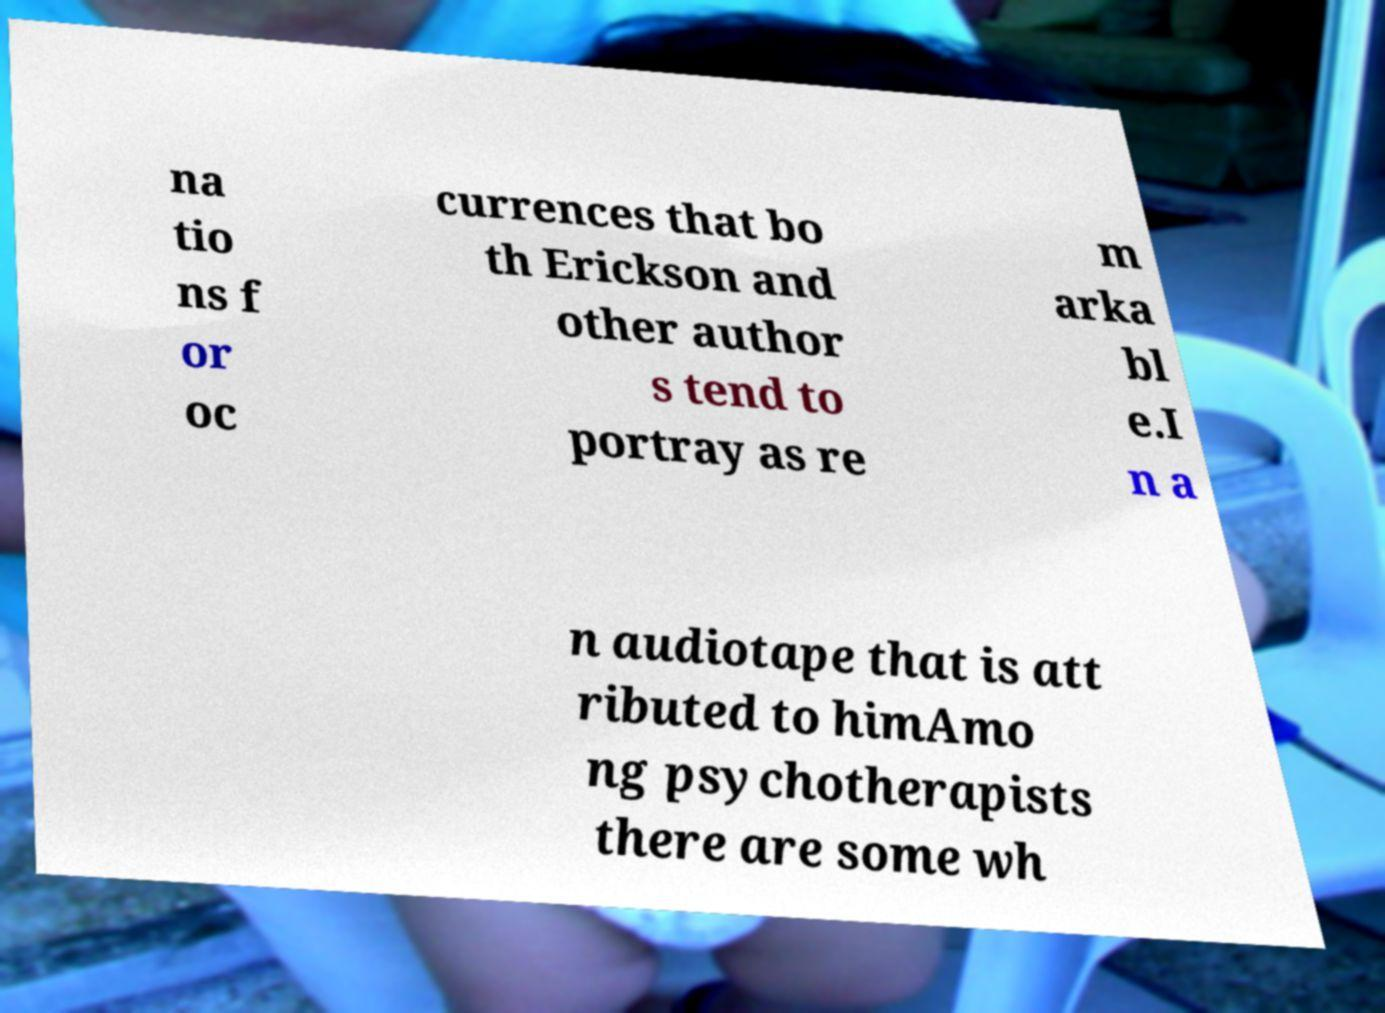Can you read and provide the text displayed in the image?This photo seems to have some interesting text. Can you extract and type it out for me? na tio ns f or oc currences that bo th Erickson and other author s tend to portray as re m arka bl e.I n a n audiotape that is att ributed to himAmo ng psychotherapists there are some wh 